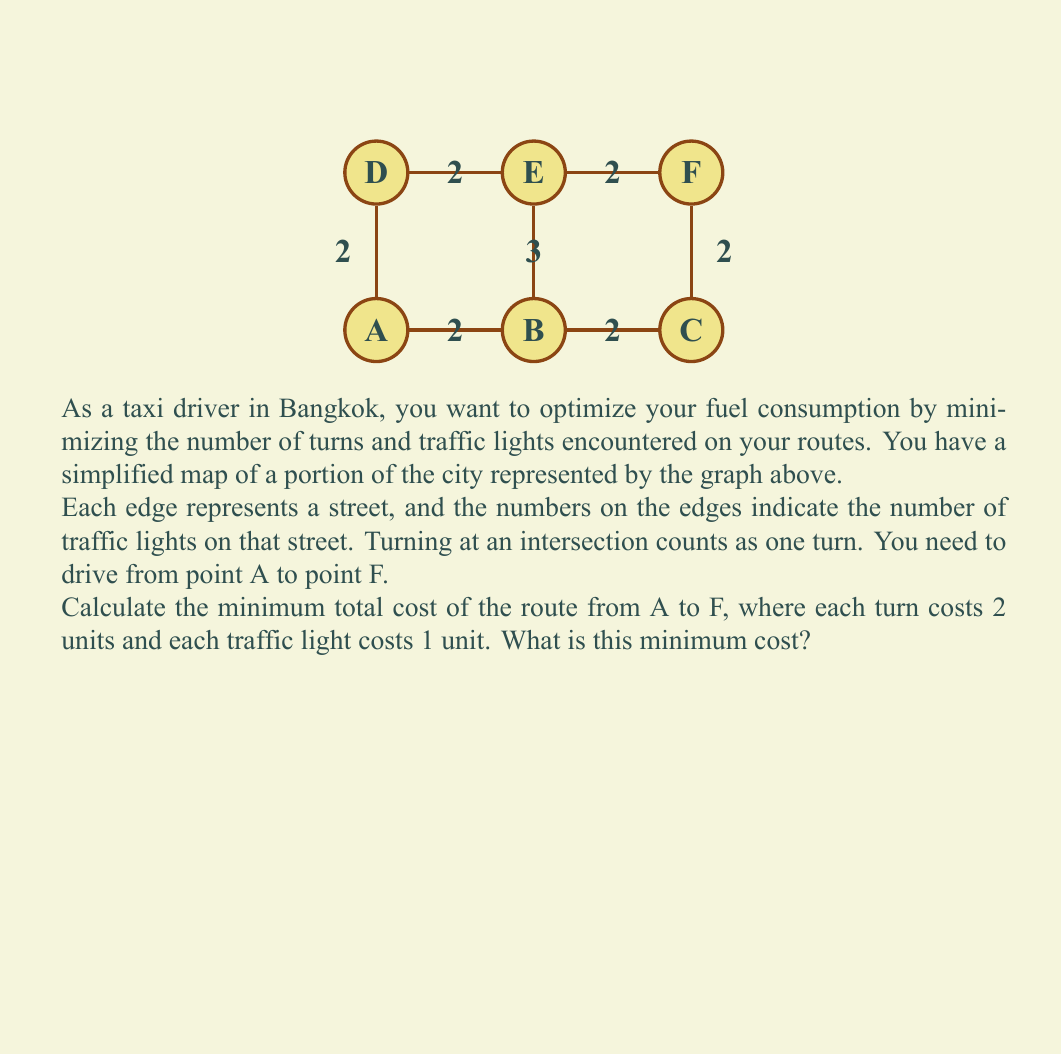Could you help me with this problem? Let's approach this step-by-step:

1) First, we need to identify all possible routes from A to F:
   - A → B → C → F
   - A → B → E → F
   - A → D → E → F

2) Now, let's calculate the cost for each route:

   Route 1: A → B → C → F
   - Turns: 2 (at B and C)
   - Traffic lights: 2 + 2 + 2 = 6
   - Total cost: $(2 \times 2) + 6 = 10$

   Route 2: A → B → E → F
   - Turns: 2 (at B and E)
   - Traffic lights: 2 + 3 + 2 = 7
   - Total cost: $(2 \times 2) + 7 = 11$

   Route 3: A → D → E → F
   - Turns: 2 (at D and E)
   - Traffic lights: 2 + 2 + 2 = 6
   - Total cost: $(2 \times 2) + 6 = 10$

3) Comparing the costs:
   Route 1: 10
   Route 2: 11
   Route 3: 10

4) We can see that Routes 1 and 3 both have the minimum cost of 10.

Therefore, the minimum total cost of the route from A to F is 10 units.
Answer: 10 units 